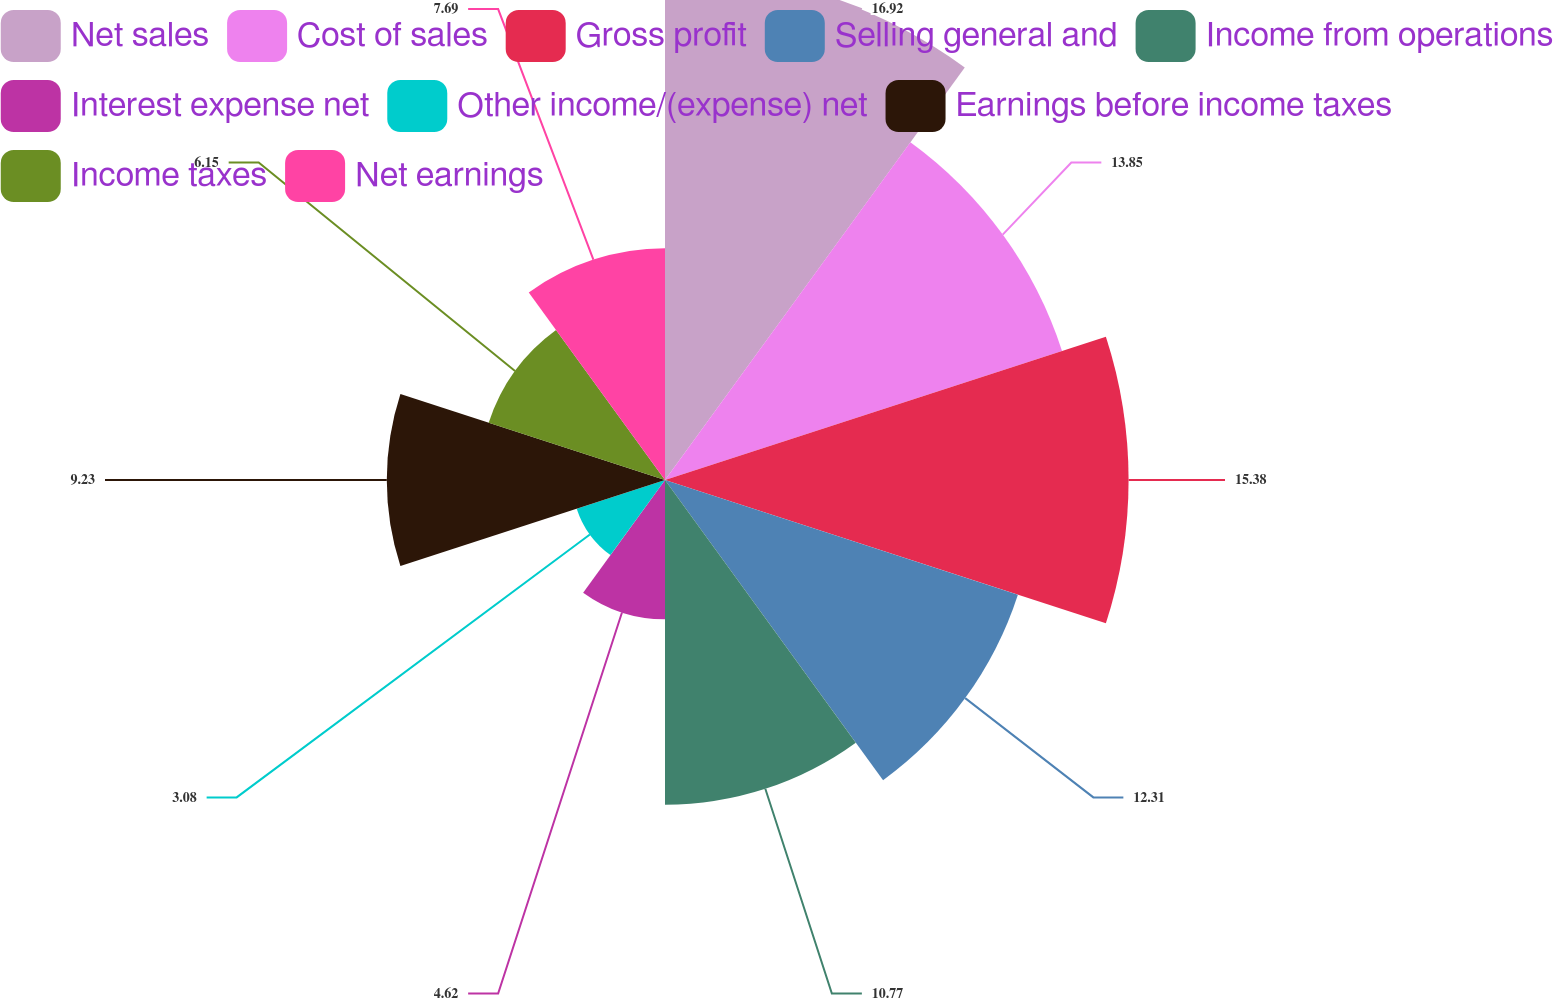<chart> <loc_0><loc_0><loc_500><loc_500><pie_chart><fcel>Net sales<fcel>Cost of sales<fcel>Gross profit<fcel>Selling general and<fcel>Income from operations<fcel>Interest expense net<fcel>Other income/(expense) net<fcel>Earnings before income taxes<fcel>Income taxes<fcel>Net earnings<nl><fcel>16.92%<fcel>13.85%<fcel>15.38%<fcel>12.31%<fcel>10.77%<fcel>4.62%<fcel>3.08%<fcel>9.23%<fcel>6.15%<fcel>7.69%<nl></chart> 